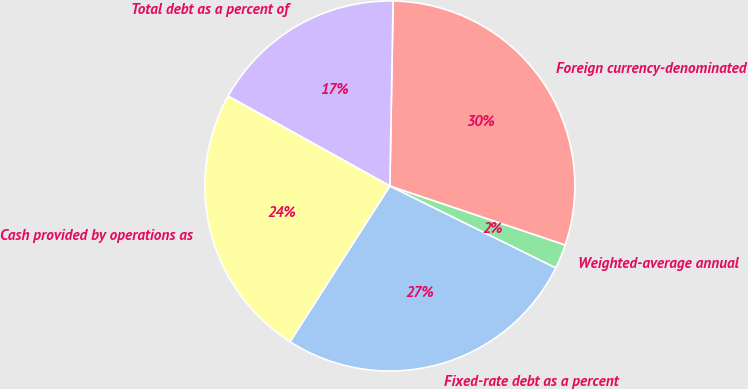Convert chart. <chart><loc_0><loc_0><loc_500><loc_500><pie_chart><fcel>Fixed-rate debt as a percent<fcel>Weighted-average annual<fcel>Foreign currency-denominated<fcel>Total debt as a percent of<fcel>Cash provided by operations as<nl><fcel>26.78%<fcel>2.13%<fcel>29.89%<fcel>17.21%<fcel>24.0%<nl></chart> 